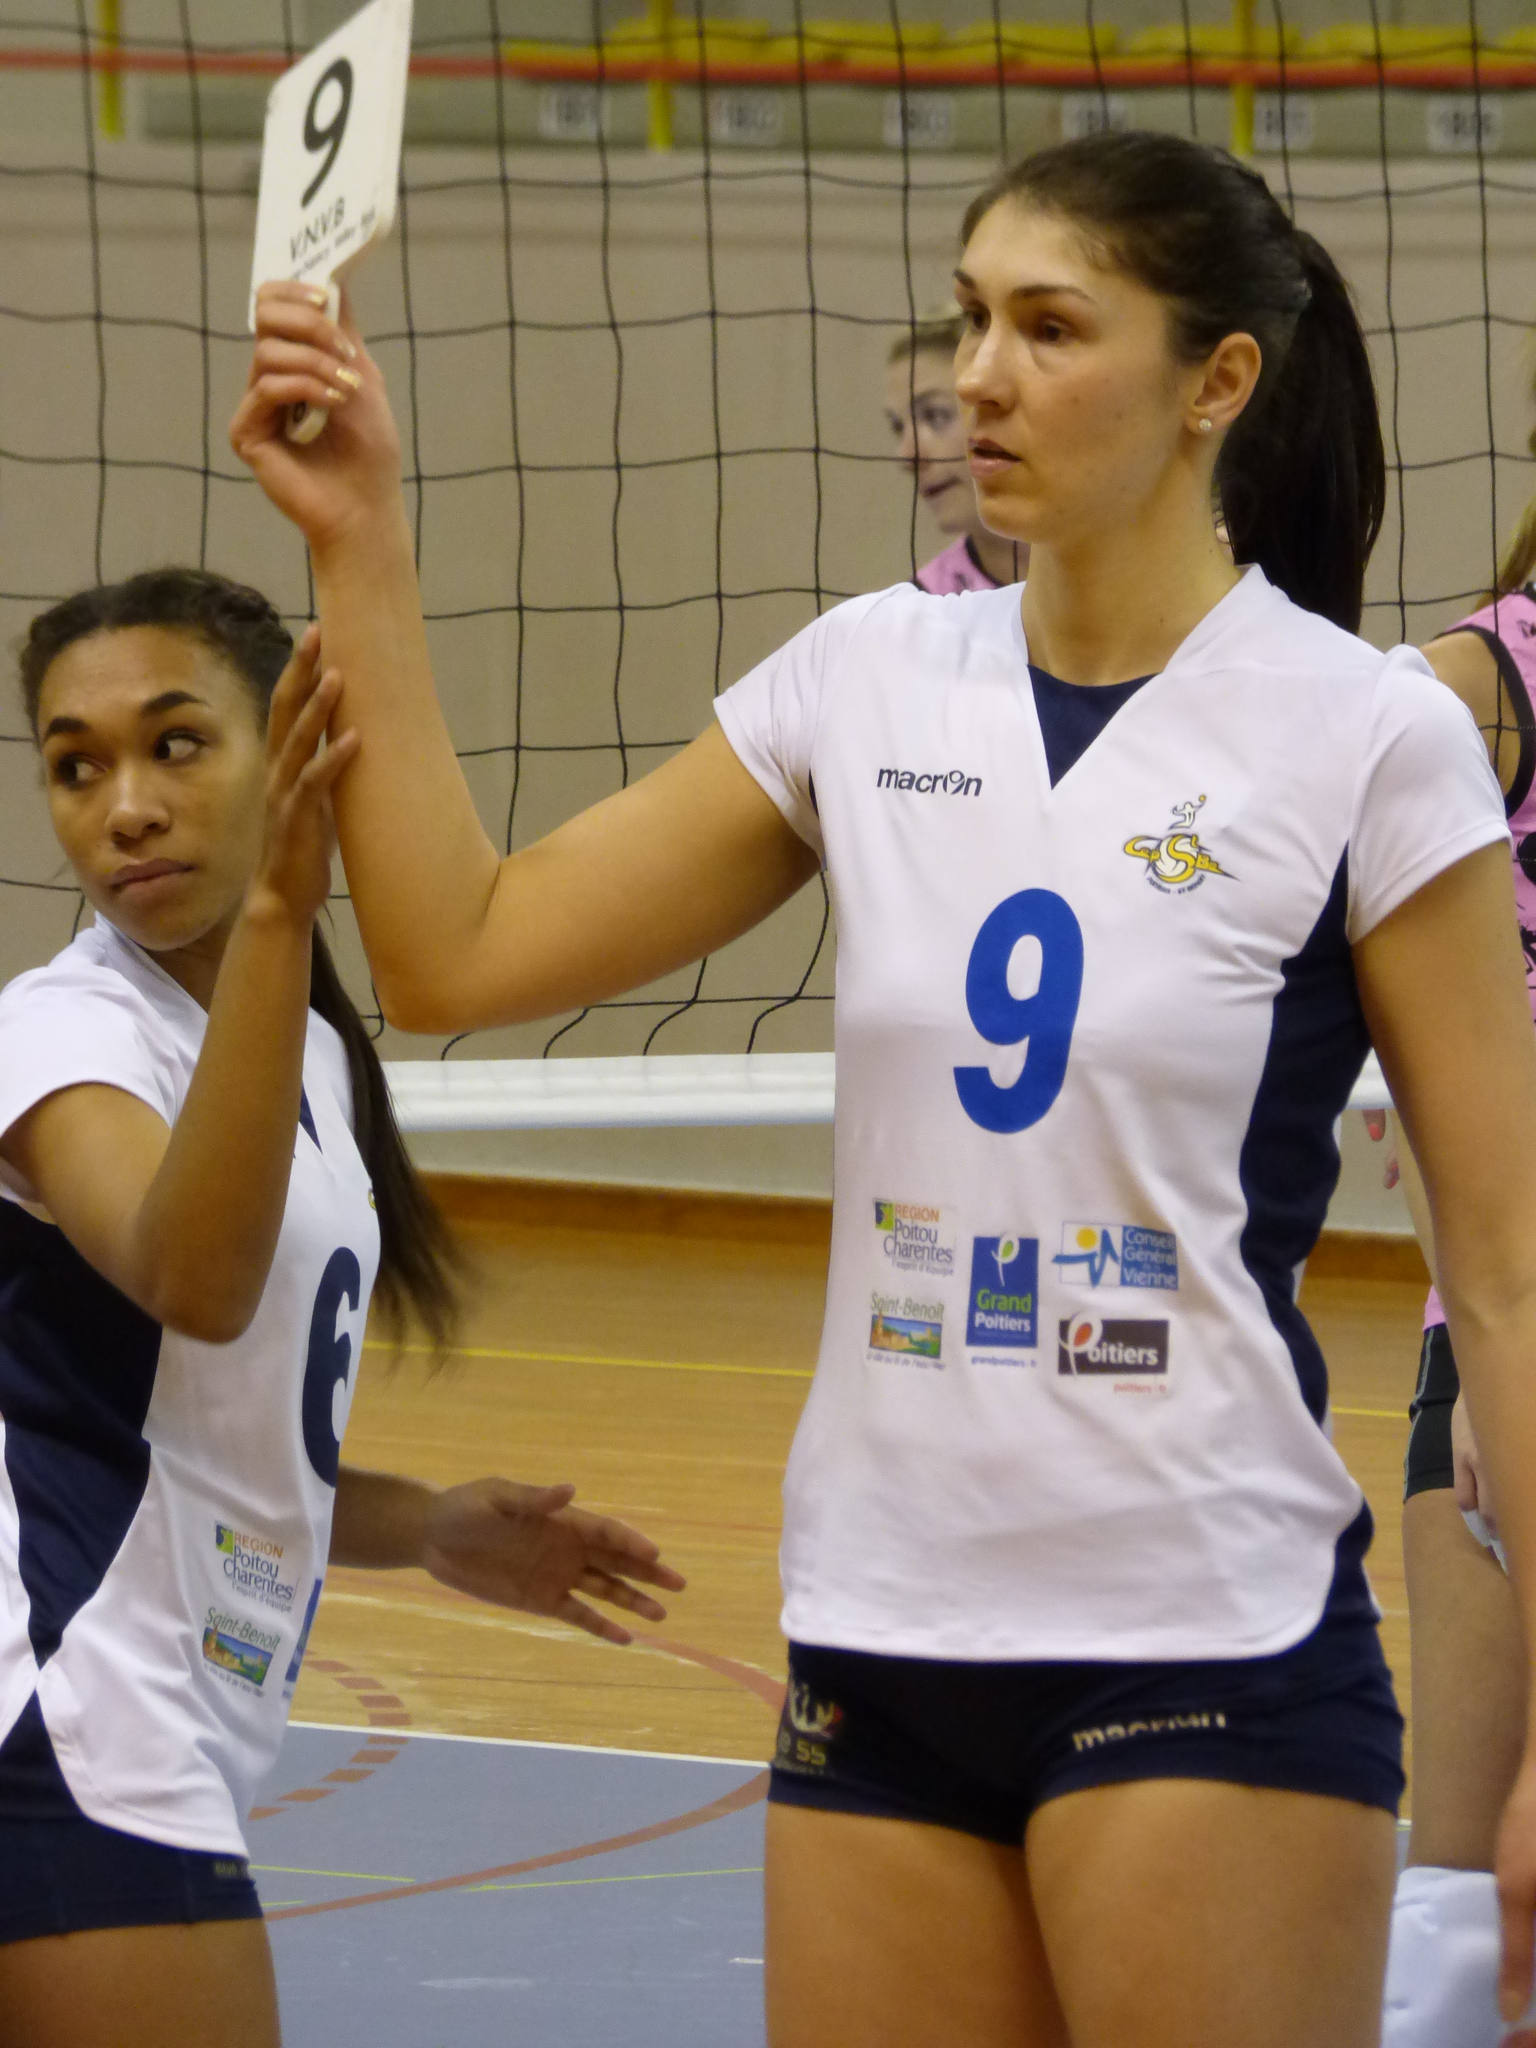<image>
Describe the image concisely. A woman wearing a volleyball jersey holds up a number 9 card. 